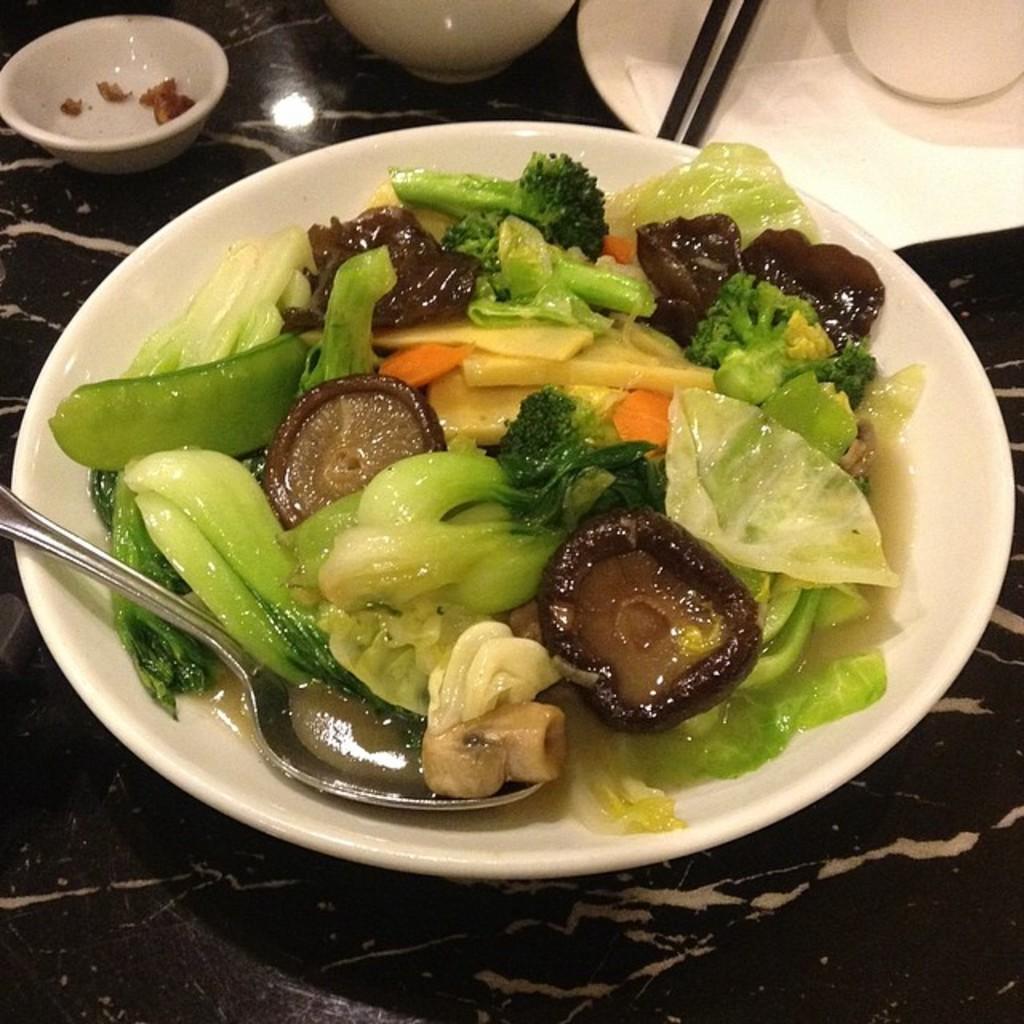In one or two sentences, can you explain what this image depicts? In this picture we can see a spoon and food in the plate, in the background we can see a bowl, chopsticks and other things on the table. 